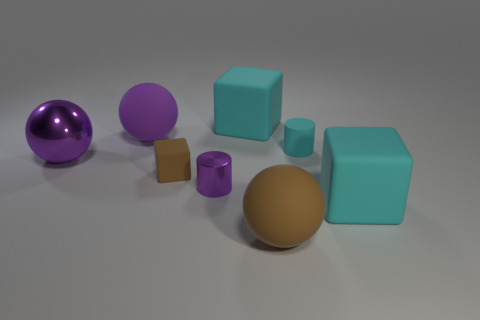Is the material of the tiny cyan object the same as the purple cylinder?
Offer a terse response. No. What number of other metallic spheres have the same size as the metal sphere?
Your response must be concise. 0. Are there the same number of brown things behind the large brown thing and large brown rubber objects?
Make the answer very short. Yes. What number of things are both to the right of the metallic ball and in front of the purple rubber thing?
Ensure brevity in your answer.  5. There is a brown thing right of the small purple shiny object; is it the same shape as the large purple rubber thing?
Offer a terse response. Yes. There is a purple ball that is the same size as the purple rubber thing; what material is it?
Provide a short and direct response. Metal. Is the number of large brown matte objects behind the small brown matte object the same as the number of tiny purple metallic things that are behind the large purple metallic sphere?
Your answer should be compact. Yes. There is a large cube that is on the right side of the big block that is behind the tiny cyan cylinder; what number of cyan things are to the left of it?
Your answer should be compact. 2. Does the tiny matte cube have the same color as the block that is behind the tiny cyan rubber cylinder?
Your response must be concise. No. There is another thing that is made of the same material as the small purple thing; what is its size?
Ensure brevity in your answer.  Large. 